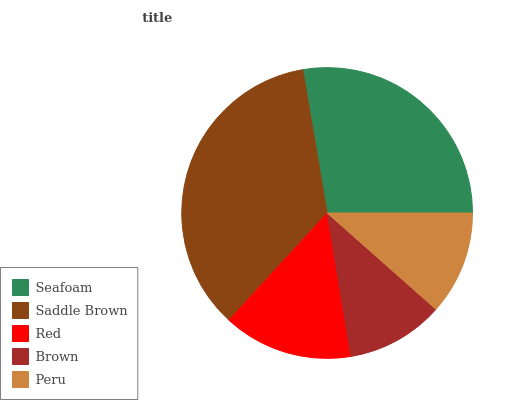Is Brown the minimum?
Answer yes or no. Yes. Is Saddle Brown the maximum?
Answer yes or no. Yes. Is Red the minimum?
Answer yes or no. No. Is Red the maximum?
Answer yes or no. No. Is Saddle Brown greater than Red?
Answer yes or no. Yes. Is Red less than Saddle Brown?
Answer yes or no. Yes. Is Red greater than Saddle Brown?
Answer yes or no. No. Is Saddle Brown less than Red?
Answer yes or no. No. Is Red the high median?
Answer yes or no. Yes. Is Red the low median?
Answer yes or no. Yes. Is Seafoam the high median?
Answer yes or no. No. Is Brown the low median?
Answer yes or no. No. 